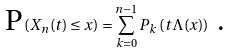Convert formula to latex. <formula><loc_0><loc_0><loc_500><loc_500>\text {P} \left ( X _ { n } ( t ) \leq x \right ) = \sum _ { k = 0 } ^ { n - 1 } P _ { k } \left ( t \Lambda ( x ) \right ) \text { .}</formula> 